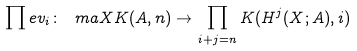Convert formula to latex. <formula><loc_0><loc_0><loc_500><loc_500>\prod e v _ { i } \colon \ m a X { K ( A , n ) } \to \prod _ { i + j = n } K ( H ^ { j } ( X ; A ) , i )</formula> 